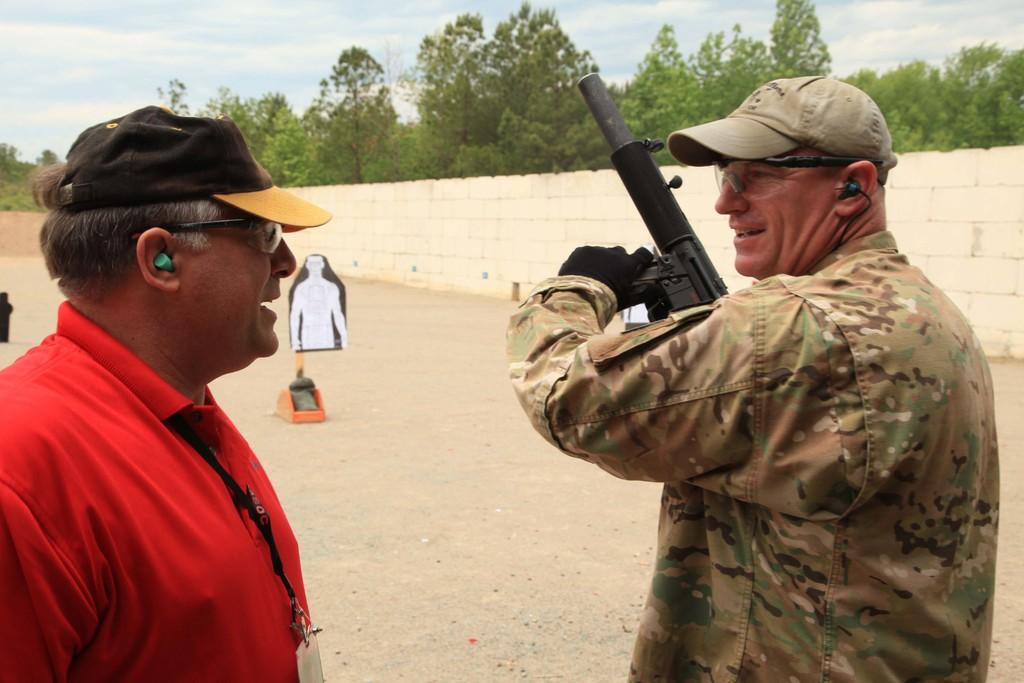What is the man in the image holding? The man is holding a gun in the image. Can you describe the other man in the image? There is another man in the foreground of the image. What type of vegetation is present in the image? There are trees in the image. What architectural feature can be seen in the image? There is a wall in the image. What is on the poster in the image? There is a man on a poster in the image. What is visible in the background of the image? The sky is visible in the background of the image. How many cattle are grazing in the image? There are no cattle present in the image. What type of pain is the man experiencing in the image? There is no indication of pain or any physical discomfort experienced by the man in the image. 